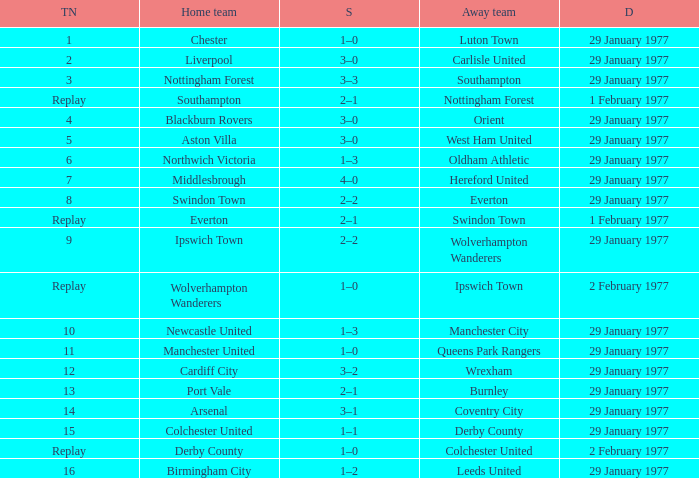When port vale plays at home, what is the tie number? 13.0. 